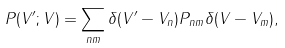Convert formula to latex. <formula><loc_0><loc_0><loc_500><loc_500>P ( V ^ { \prime } ; V ) = \sum _ { n m } \delta ( V ^ { \prime } - V _ { n } ) P _ { n m } \delta ( V - V _ { m } ) ,</formula> 